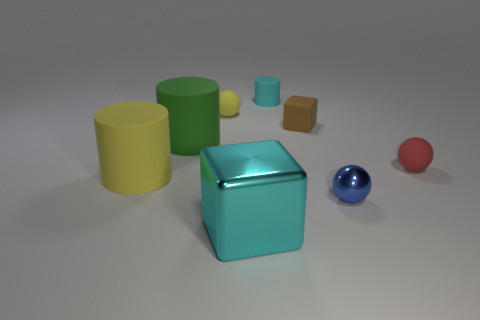What color is the shiny thing to the left of the cylinder right of the large metal cube?
Provide a succinct answer. Cyan. There is a block that is the same size as the blue thing; what is its color?
Make the answer very short. Brown. Are there any other cubes that have the same color as the rubber block?
Offer a very short reply. No. Are there any tiny rubber cylinders?
Your answer should be compact. Yes. The yellow matte object in front of the green rubber object has what shape?
Ensure brevity in your answer.  Cylinder. How many objects are both on the left side of the small matte block and in front of the brown cube?
Provide a short and direct response. 3. What number of other things are there of the same size as the red sphere?
Provide a succinct answer. 4. There is a shiny object on the right side of the small cyan thing; does it have the same shape as the cyan object that is in front of the tiny rubber cylinder?
Your answer should be compact. No. What number of objects are large cyan blocks or tiny things behind the small red thing?
Your answer should be very brief. 4. What material is the big object that is both behind the large cyan block and in front of the large green matte object?
Make the answer very short. Rubber. 